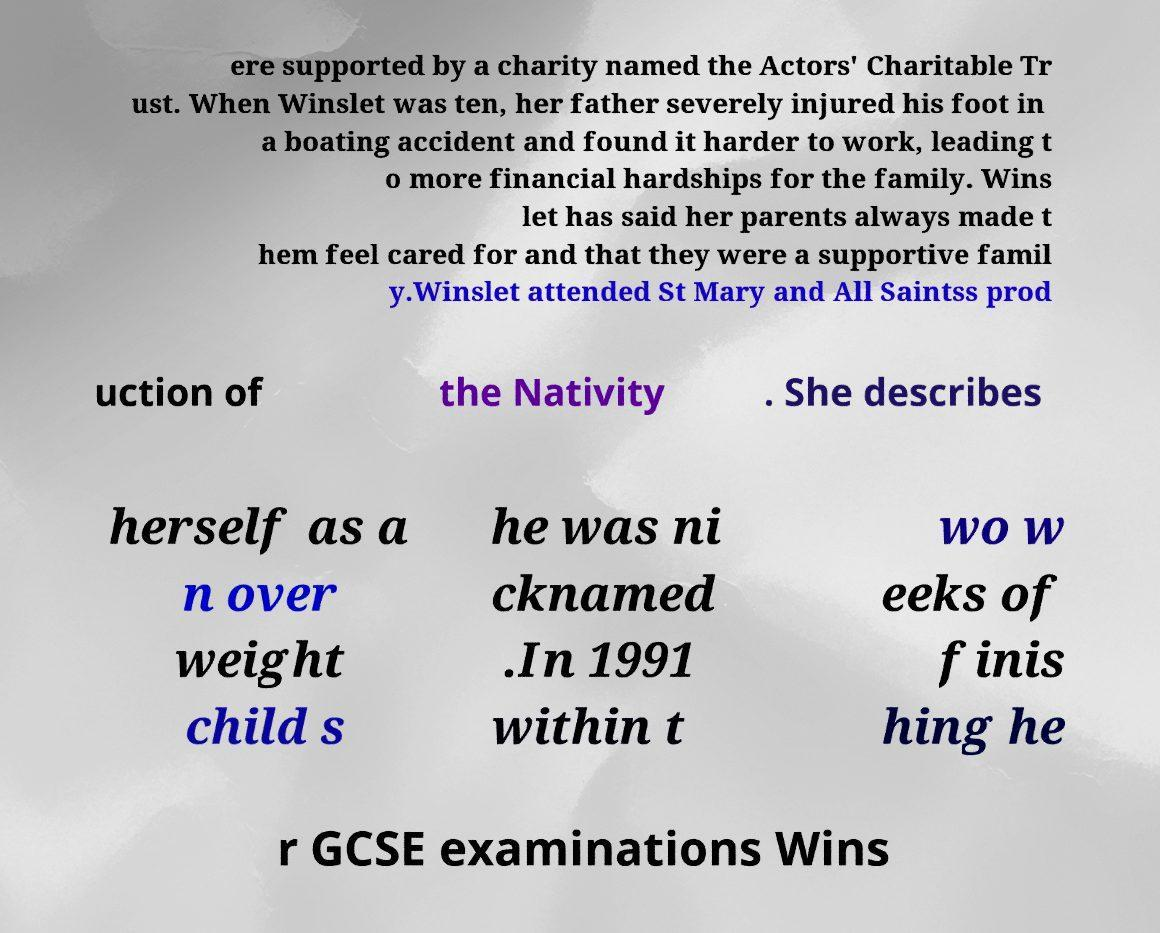I need the written content from this picture converted into text. Can you do that? ere supported by a charity named the Actors' Charitable Tr ust. When Winslet was ten, her father severely injured his foot in a boating accident and found it harder to work, leading t o more financial hardships for the family. Wins let has said her parents always made t hem feel cared for and that they were a supportive famil y.Winslet attended St Mary and All Saintss prod uction of the Nativity . She describes herself as a n over weight child s he was ni cknamed .In 1991 within t wo w eeks of finis hing he r GCSE examinations Wins 